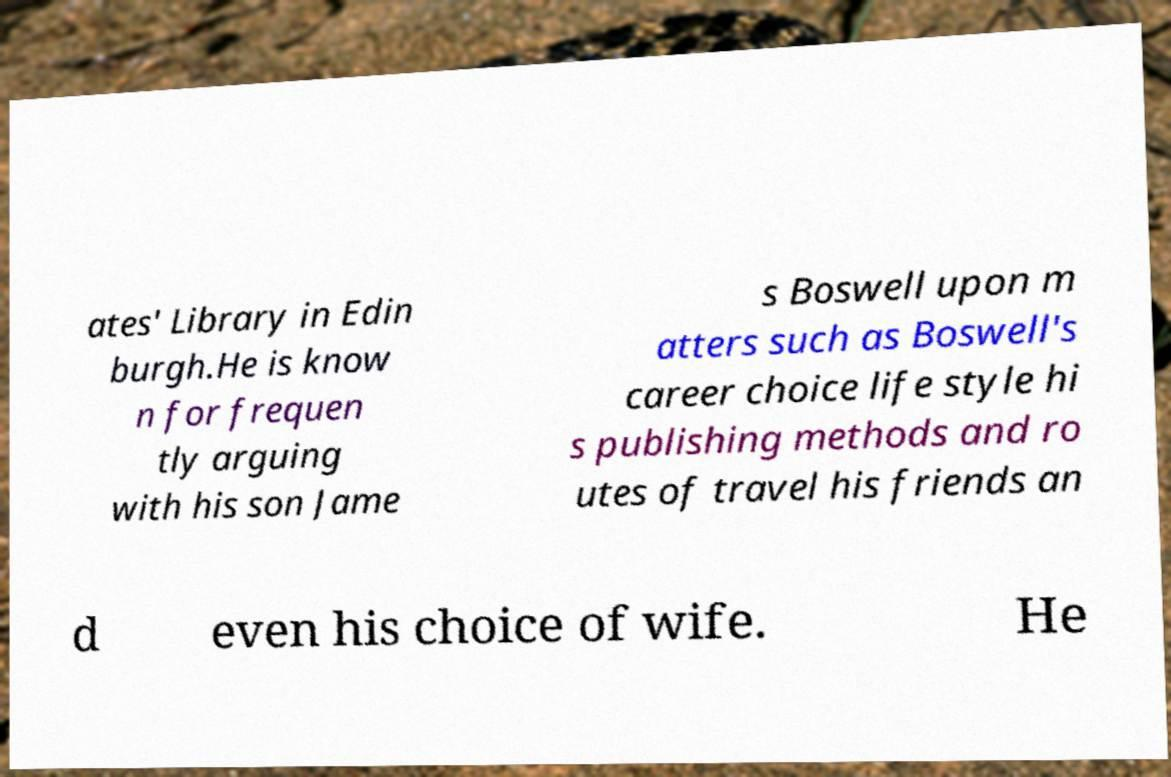Could you extract and type out the text from this image? ates' Library in Edin burgh.He is know n for frequen tly arguing with his son Jame s Boswell upon m atters such as Boswell's career choice life style hi s publishing methods and ro utes of travel his friends an d even his choice of wife. He 